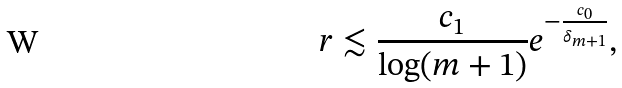Convert formula to latex. <formula><loc_0><loc_0><loc_500><loc_500>r \lesssim \frac { c _ { 1 } } { \log ( m + 1 ) } e ^ { - \frac { c _ { 0 } } { \delta _ { m + 1 } } } ,</formula> 